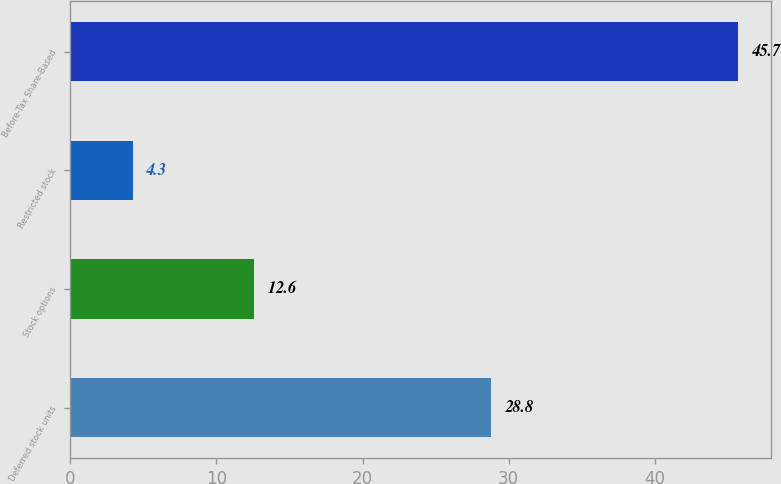Convert chart. <chart><loc_0><loc_0><loc_500><loc_500><bar_chart><fcel>Deferred stock units<fcel>Stock options<fcel>Restricted stock<fcel>Before-Tax Share-Based<nl><fcel>28.8<fcel>12.6<fcel>4.3<fcel>45.7<nl></chart> 